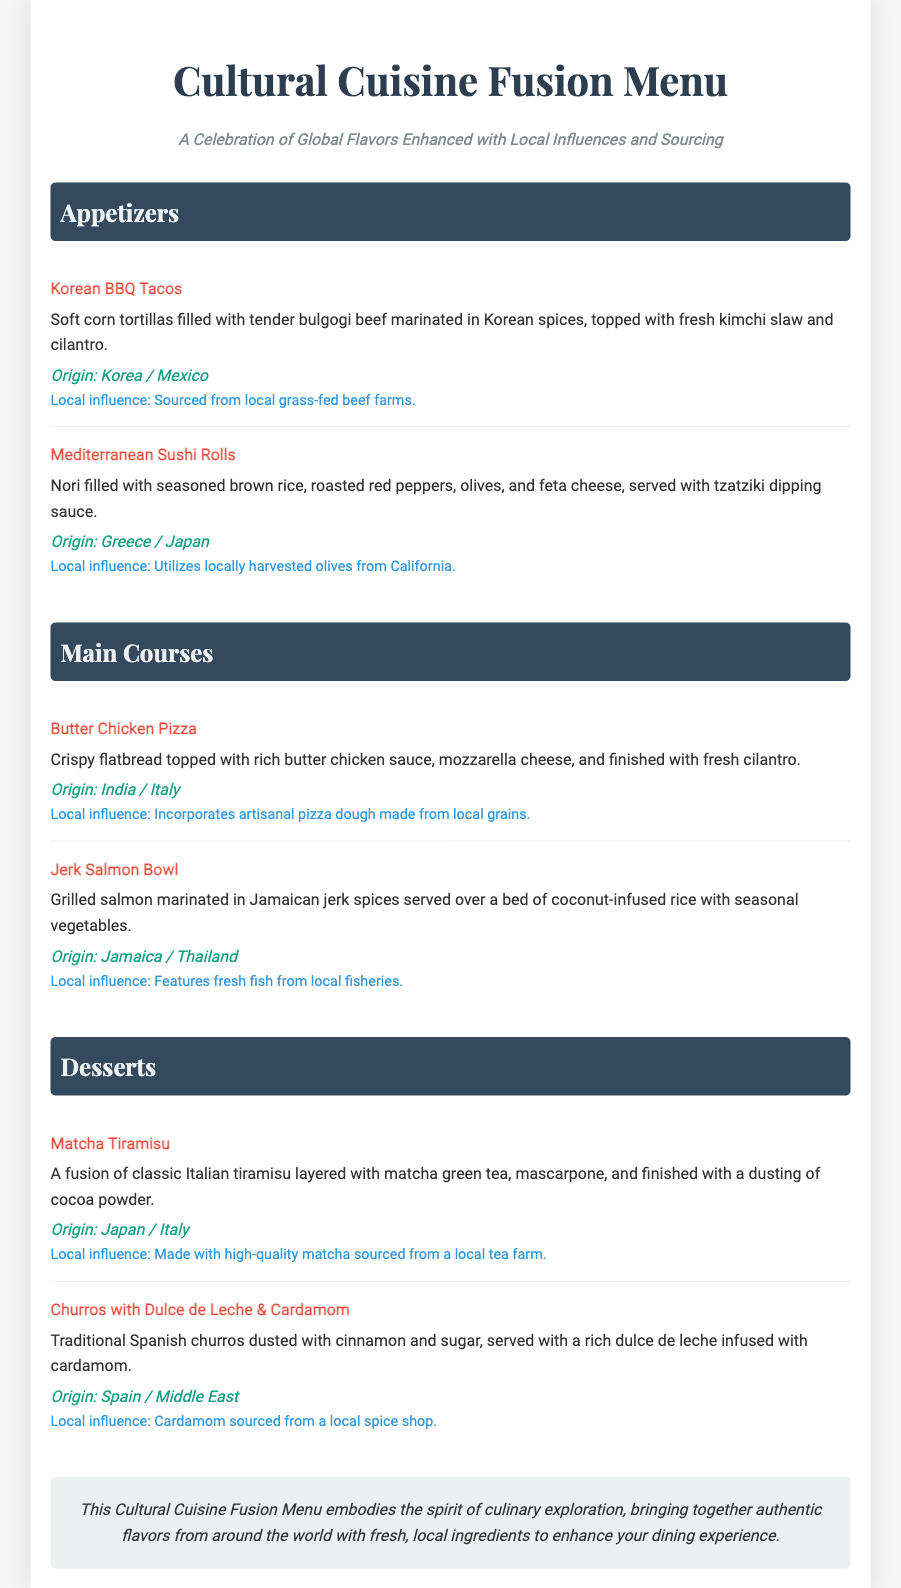What are the appetizers listed? The appetizers are Korean BBQ Tacos and Mediterranean Sushi Rolls.
Answer: Korean BBQ Tacos, Mediterranean Sushi Rolls What is the local influence of the Butter Chicken Pizza? The local influence is that it incorporates artisanal pizza dough made from local grains.
Answer: Artisanal pizza dough made from local grains From which farms is the matcha in the Matcha Tiramisu sourced? The matcha is sourced from a local tea farm.
Answer: Local tea farm How many main courses are on the menu? The main courses listed are Butter Chicken Pizza and Jerk Salmon Bowl, totaling two.
Answer: 2 What type of cuisine is represented in the Korean BBQ Tacos? The cuisine represented is a fusion of Korean and Mexican.
Answer: Korean / Mexican What dessert is served with dulce de leche? The dessert served with dulce de leche is Churros.
Answer: Churros What is the origin of the Jerk Salmon Bowl? The origin of the Jerk Salmon Bowl is Jamaica and Thailand.
Answer: Jamaica / Thailand What local ingredient is used in the Churros dessert? The local ingredient used is cardamom sourced from a local spice shop.
Answer: Cardamom from a local spice shop 